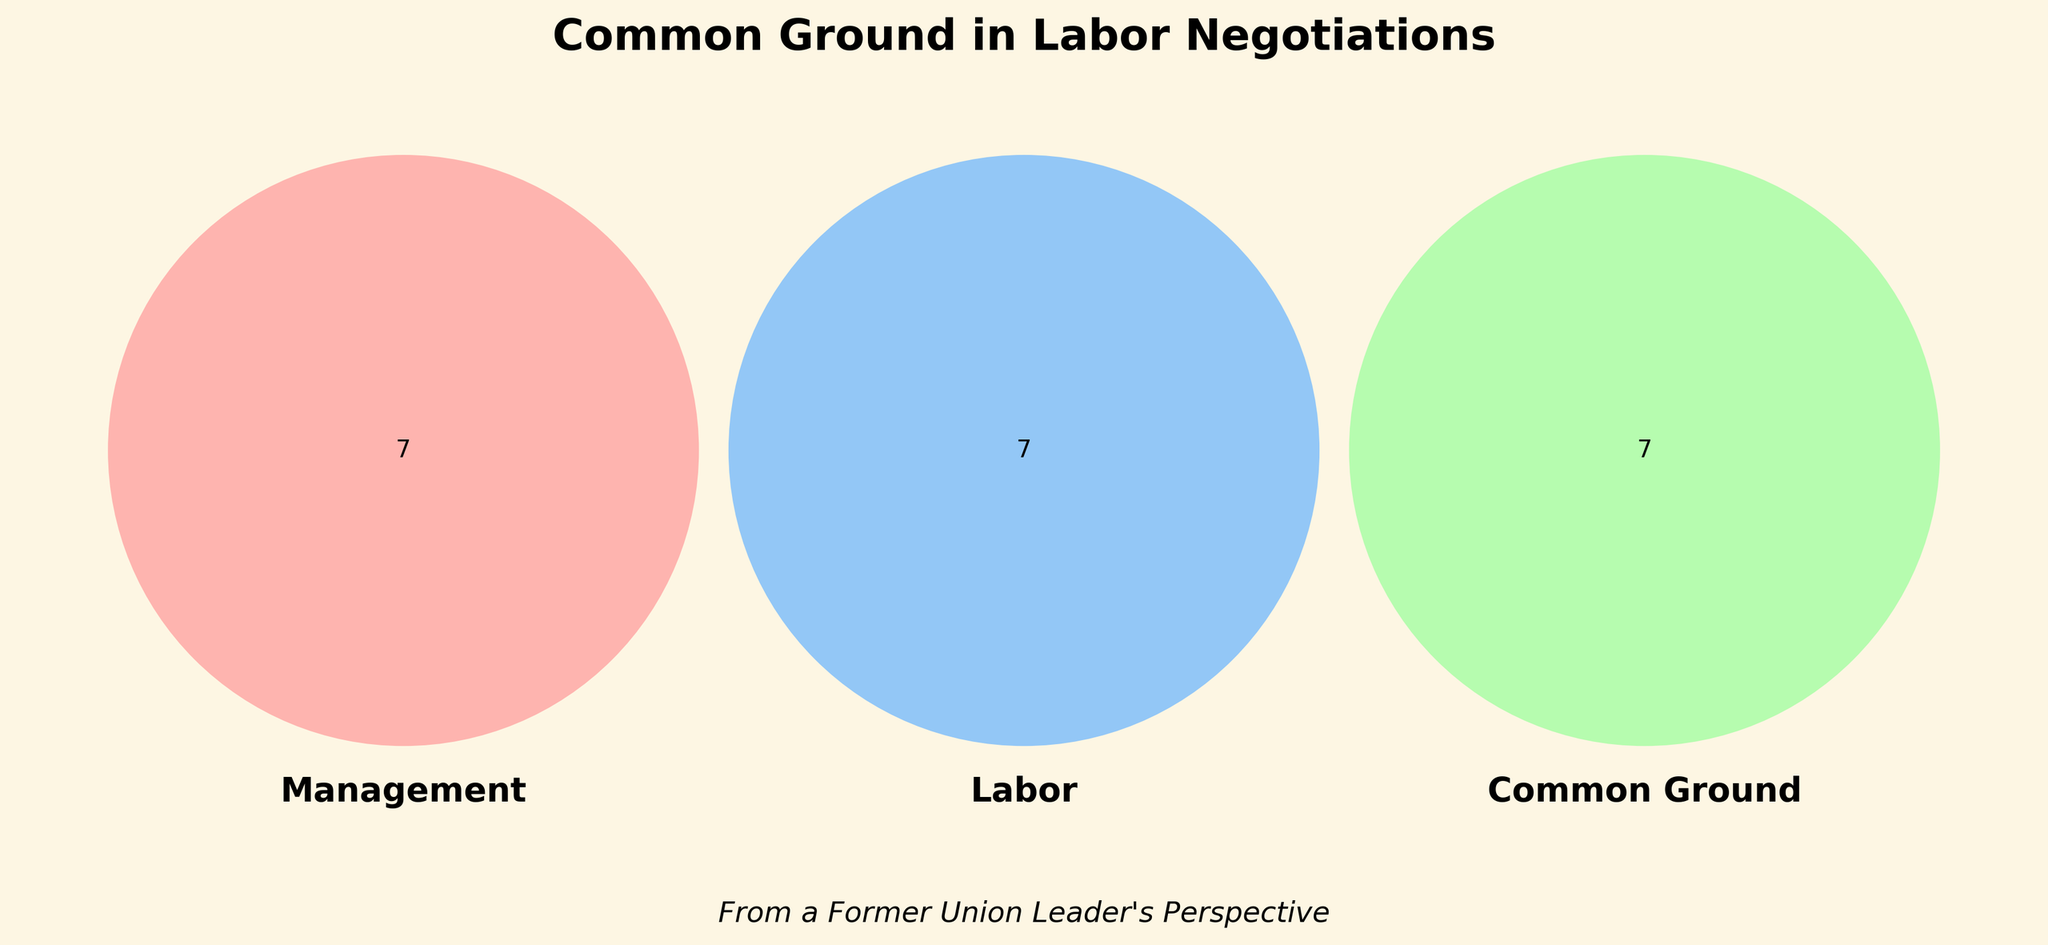What is the title of the Venn diagram? The title is located at the top of the Venn diagram and indicates the main topic of the diagram.
Answer: Common Ground in Labor Negotiations How many different areas are represented in the Venn diagram? A Venn diagram with three circles represents seven distinct areas including all combinations of overlap and uniqueness.
Answer: Seven What are some common grounds between management and labor? The ‘Common Ground’ part of the Venn diagram has text describing shared interests between management and labor.
Answer: Fair compensation, Workplace safety, Improved benefits, Productivity incentives, Clear communication channels, Company growth, Employee retention Which unique concern belongs to both management and labor, but not part of the common ground? Identify traits listed only under the 'Management' or 'Labor' sections that are not shared in the common ground area.
Answer: None What is unique to management's interests in labor negotiations? The Venn diagram's 'Management' section lists interests that are unique to management.
Answer: Cost reduction, Efficiency improvements, Profit maximization, Flexible scheduling, Performance metrics, Market competitiveness, Outsourcing options Which interests in the Venn diagram are specific to labor? The Venn diagram's 'Labor' section lists interests that are unique to labor.
Answer: Job security, Work-life balance, Higher wages, Overtime pay, Training opportunities, Collective bargaining rights, Union representation Are flexible scheduling and higher wages common interests? Verify if both 'Flexible scheduling' and 'Higher wages' are in the common ground section of the Venn diagram.
Answer: No What do workplace safety and productivity incentives have in common? Locate ‘Workplace safety’ and ‘Productivity incentives’ in the common ground section of the Venn diagram, if both exist.
Answer: Both are common ground Which areas in the Venn diagram indicate the most shared interests? The common ground section shows the greatest number of shared interests between management and labor.
Answer: Common ground 